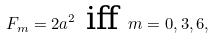<formula> <loc_0><loc_0><loc_500><loc_500>F _ { m } = 2 a ^ { 2 } \text { iff } m = 0 , 3 , 6 ,</formula> 